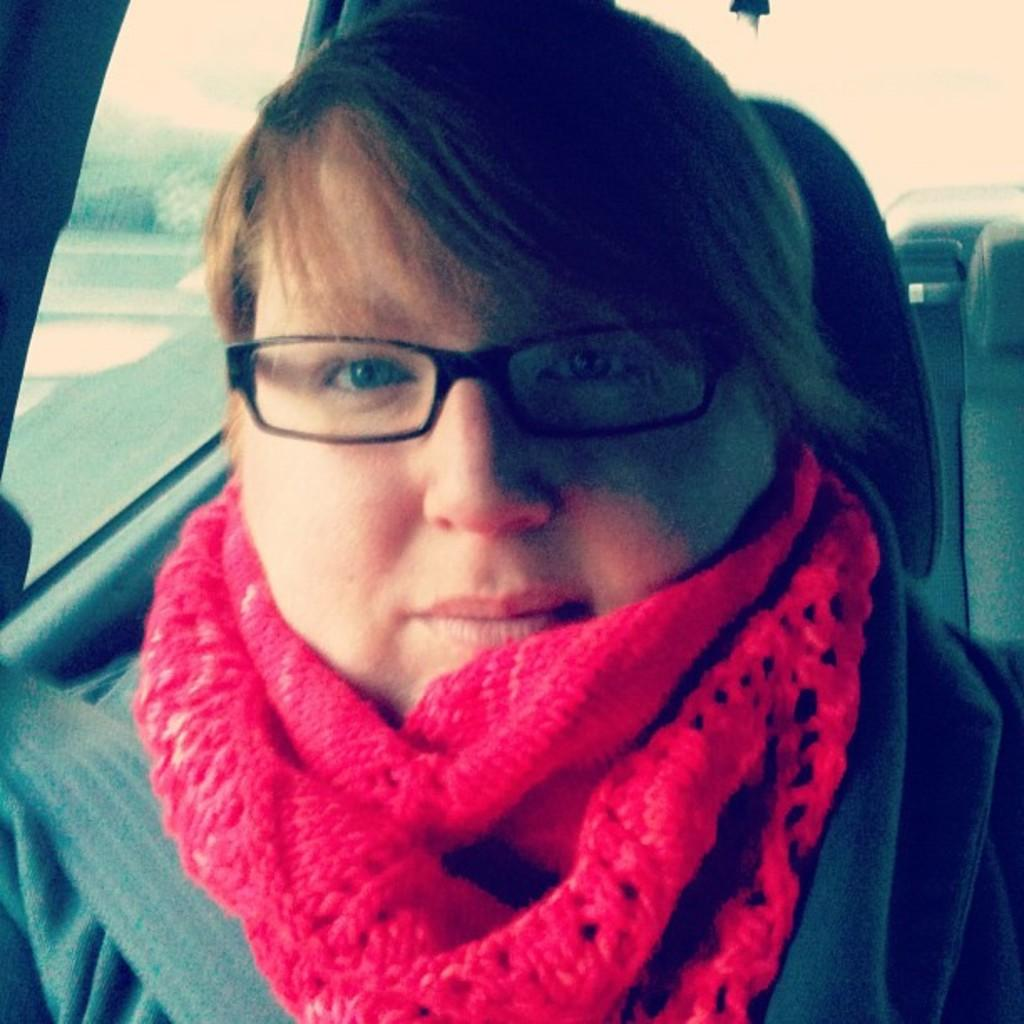Who is present in the image? There is a woman in the image. What is the woman doing in the image? The woman is sitting in a vehicle. What can be seen in the background of the image? There are plants in the background of the image. What books is the woman reading in the image? There are no books visible in the image, as the woman is sitting in a vehicle with plants in the background. 